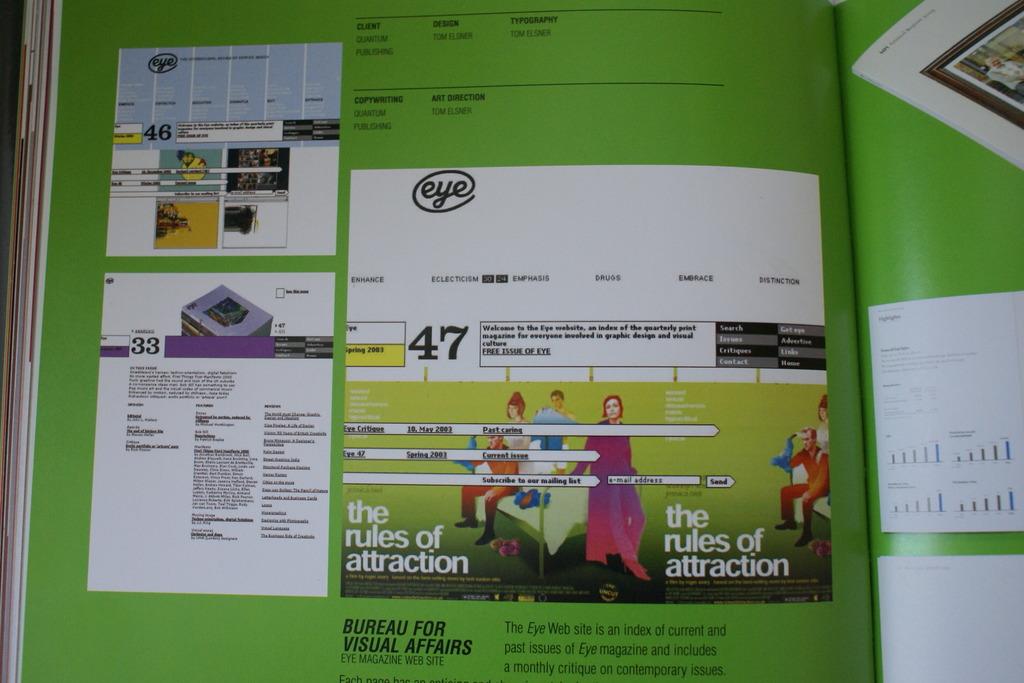What rules are mentioned on the image?
Your answer should be compact. Attraction. What is the brand in the publication?
Ensure brevity in your answer.  Eye. 